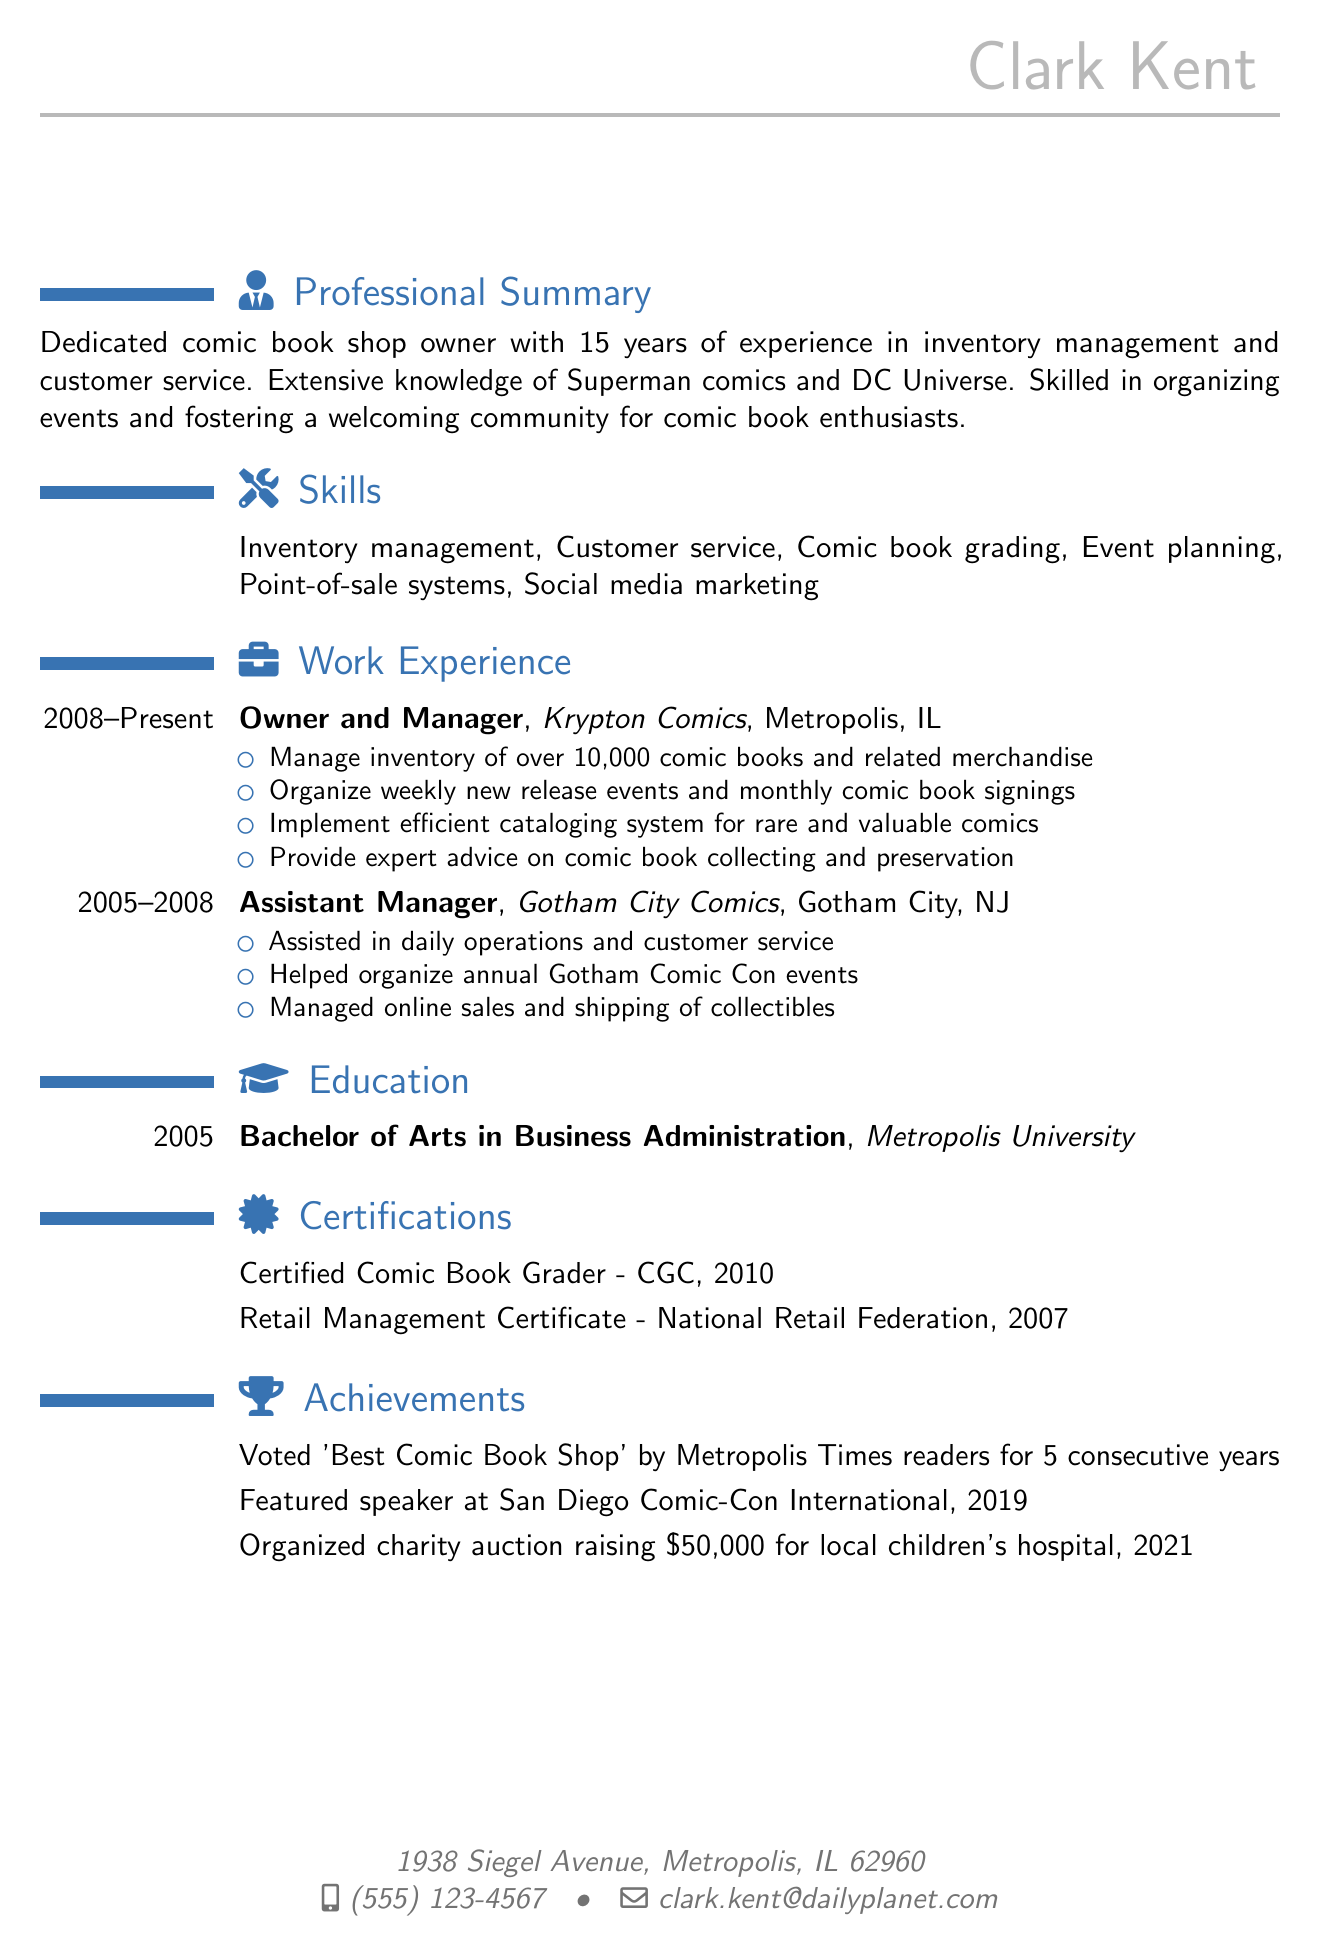What is the name of the comic book shop owned by Clark Kent? The document lists Krypton Comics as the comic book shop owned and managed by Clark Kent.
Answer: Krypton Comics How many years of experience does Clark Kent have in the industry? The summary section of the document states that Clark Kent has 15 years of experience in inventory management and customer service.
Answer: 15 years What degree did Clark Kent obtain? The education section specifies that Clark Kent earned a Bachelor of Arts in Business Administration from Metropolis University.
Answer: Bachelor of Arts in Business Administration What certification was obtained in 2010? The certifications section indicates that Clark Kent became a Certified Comic Book Grader in 2010.
Answer: Certified Comic Book Grader How many consecutive years was Krypton Comics voted 'Best Comic Book Shop'? The achievements section states that Krypton Comics was voted 'Best Comic Book Shop' by Metropolis Times readers for 5 consecutive years.
Answer: 5 What is one of Clark Kent's responsibilities as the owner of Krypton Comics? The work experience section lists multiple responsibilities, one of which is managing an inventory of over 10,000 comic books and related merchandise.
Answer: Manage inventory of over 10,000 comic books Which city did Clark Kent work in as an Assistant Manager? The work experience section reveals that Clark Kent worked in Gotham City, NJ, as an Assistant Manager at Gotham City Comics.
Answer: Gotham City, NJ What major event did Clark Kent help organize while at Gotham City Comics? The responsibilities listed for the Assistant Manager position include helping to organize the annual Gotham Comic Con events.
Answer: Annual Gotham Comic Con What was the amount raised in the charity auction organized by Clark Kent? The achievements section confirms that the charity auction organized by Clark Kent raised $50,000 for a local children's hospital.
Answer: $50,000 